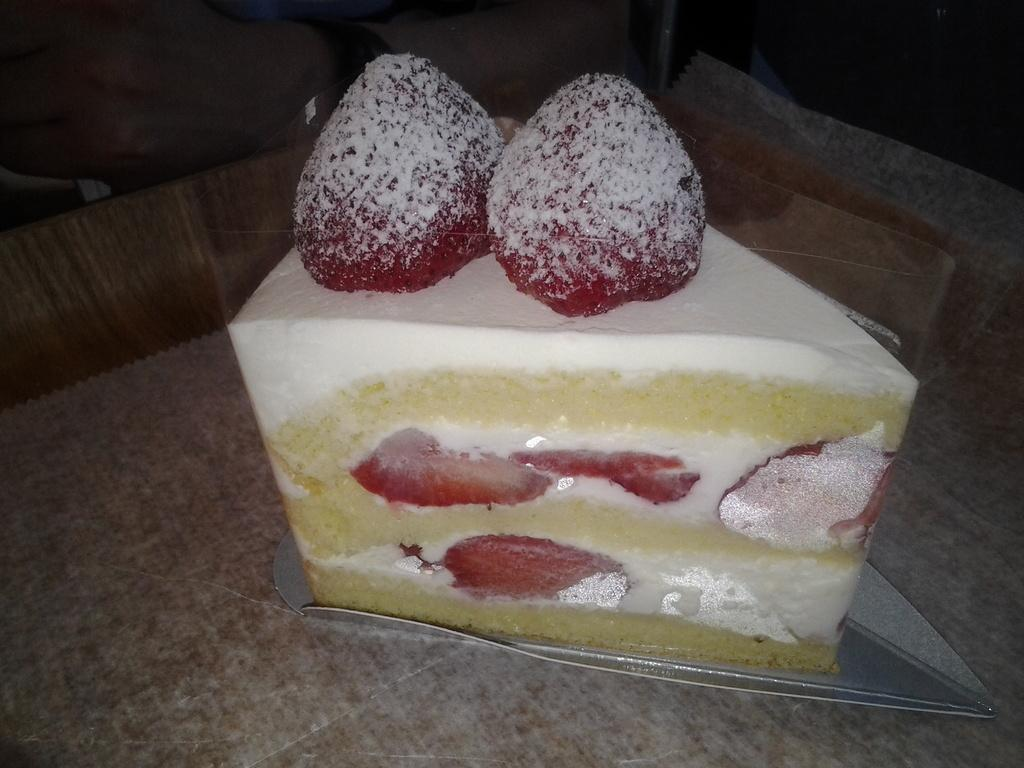What type of food is featured in the image? There is a pastry in the image. What is on top of the pastry? The pastry is topped with two strawberries. Where is the pastry located? The pastry is on a table. What riddle is the pastry trying to solve in the image? There is no riddle present in the image; it is a pastry with two strawberries on top. 